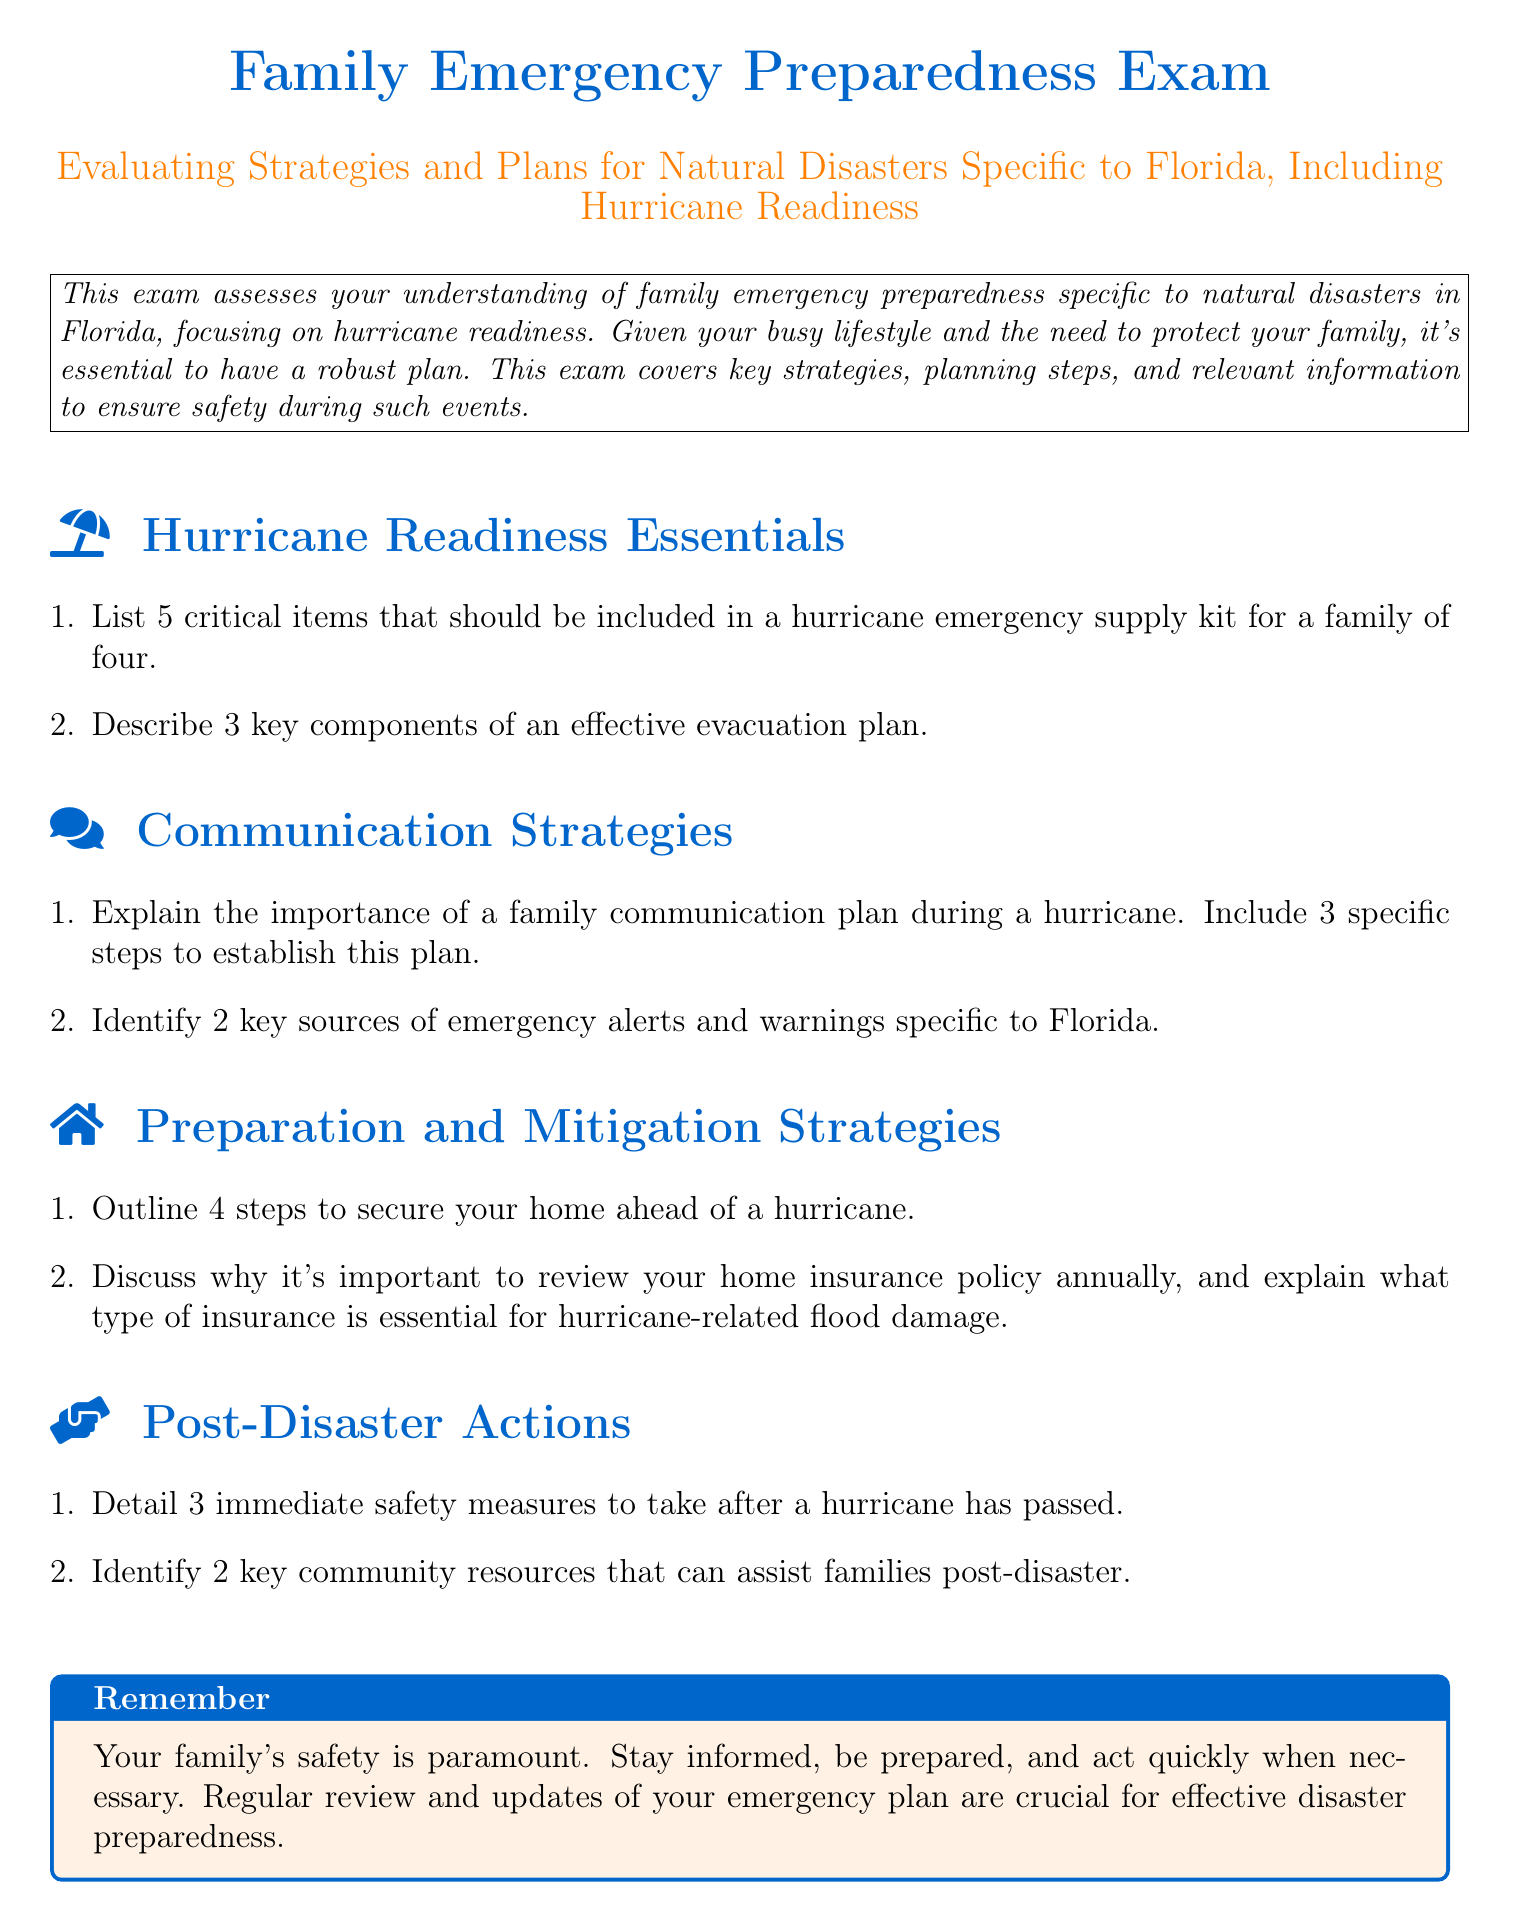What is the title of the exam? The title appears at the top of the document and identifies the purpose of the content, which is focused on family emergency preparedness.
Answer: Family Emergency Preparedness Exam What color is used for the title? The color used for the title is specifically designed to stand out and is mentioned in the color definition, which describes a shade of blue.
Answer: Floridablue How many critical items should be included in a hurricane emergency supply kit? The document specifies that five critical items should be included in the emergency supply kit.
Answer: 5 What are three key components of an effective evacuation plan? The document mentions the need for understanding key components of an evacuation plan, but does not specify those in the provided text.
Answer: Not specified What is one reason to review your home insurance policy annually? The document explains the importance of reviewing home insurance policies for ensuring adequate coverage, specifically in relation to natural disasters.
Answer: Adequate coverage How many immediate safety measures are suggested after a hurricane? The document states that three immediate safety measures are to be taken post-hurricane.
Answer: 3 Name one key community resource that can assist families post-disaster. The document emphasizes the availability of community resources, which include assistance for families affected by disasters.
Answer: Not specified What color is used for the reminder box at the end of the document? The reminder box's background color is mentioned in the document and it complements the title's color scheme.
Answer: Hurricaneorange List two key sources of emergency alerts in Florida. The document indicates the need to identify sources of emergency alerts but does not specify them in the provided text.
Answer: Not specified 